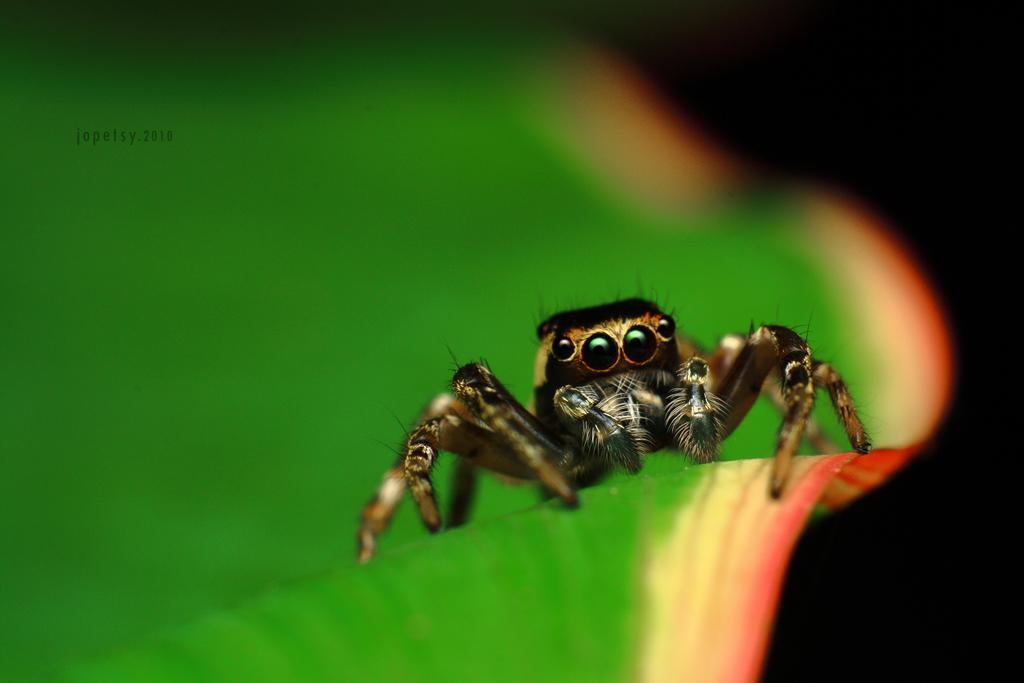What is on the leaf in the image? There is an insect on a leaf in the image. What can be seen on the left side of the image? There is text on the left side of the image. What color is the background on the right side of the image? The background on the right side of the image is black. Can you tell me how many flowers the insect is touching in the image? There are no flowers present in the image, so it is not possible to determine how many the insect might be touching. 